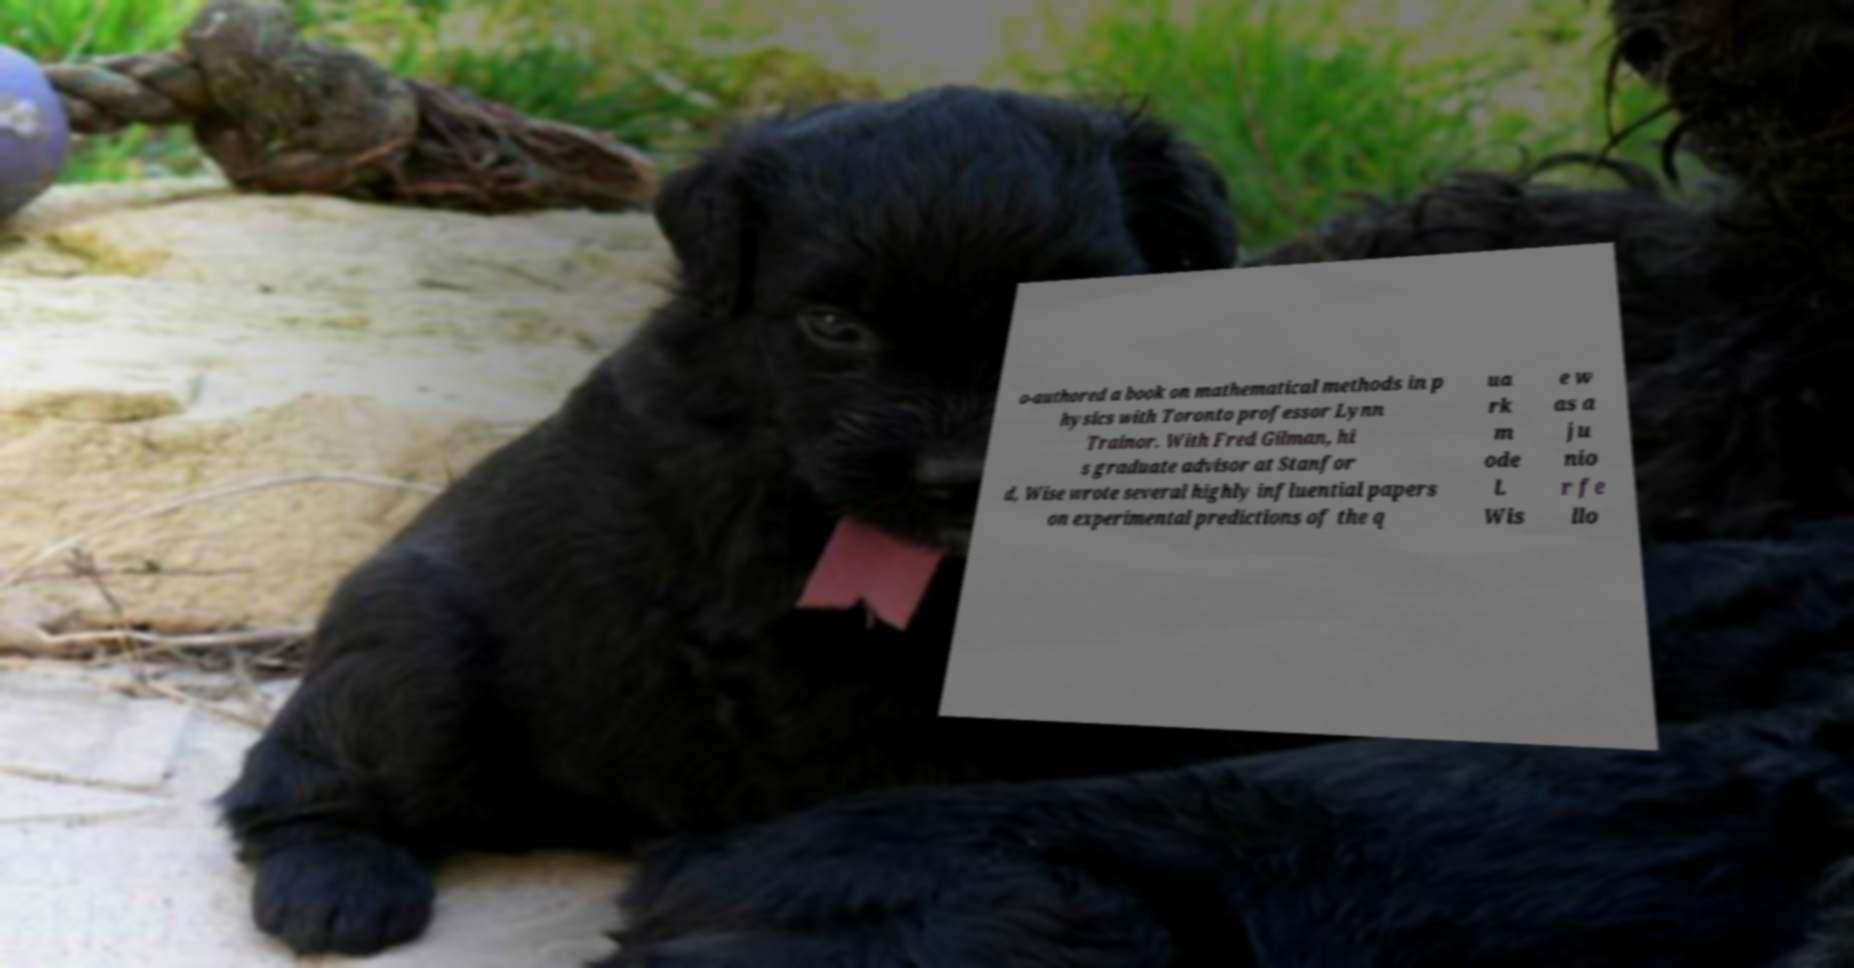I need the written content from this picture converted into text. Can you do that? o-authored a book on mathematical methods in p hysics with Toronto professor Lynn Trainor. With Fred Gilman, hi s graduate advisor at Stanfor d, Wise wrote several highly influential papers on experimental predictions of the q ua rk m ode l. Wis e w as a ju nio r fe llo 